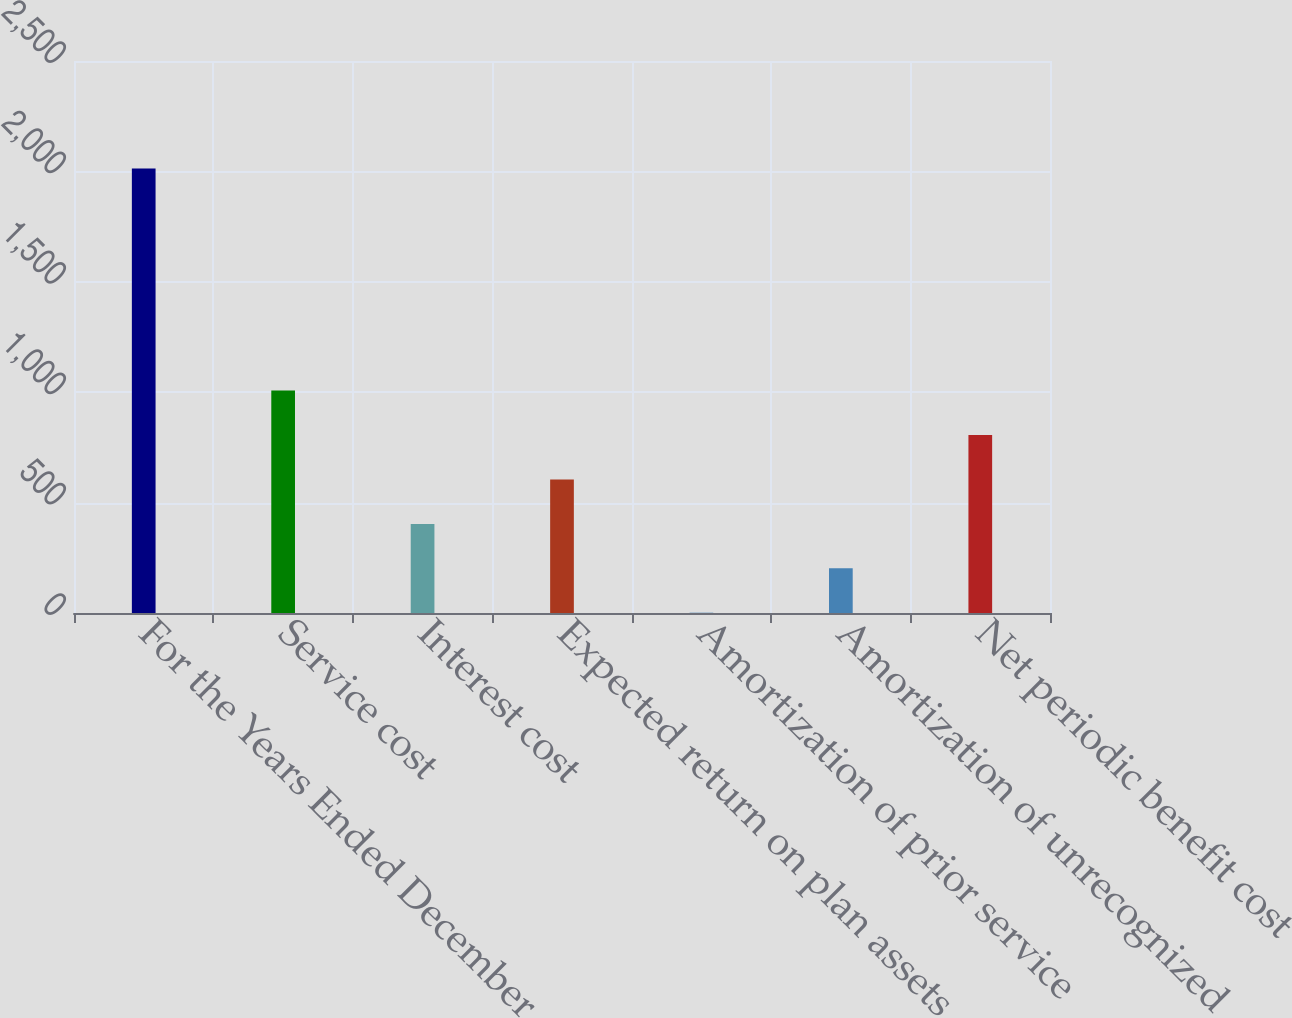Convert chart to OTSL. <chart><loc_0><loc_0><loc_500><loc_500><bar_chart><fcel>For the Years Ended December<fcel>Service cost<fcel>Interest cost<fcel>Expected return on plan assets<fcel>Amortization of prior service<fcel>Amortization of unrecognized<fcel>Net periodic benefit cost<nl><fcel>2013<fcel>1007.15<fcel>403.64<fcel>604.81<fcel>1.3<fcel>202.47<fcel>805.98<nl></chart> 